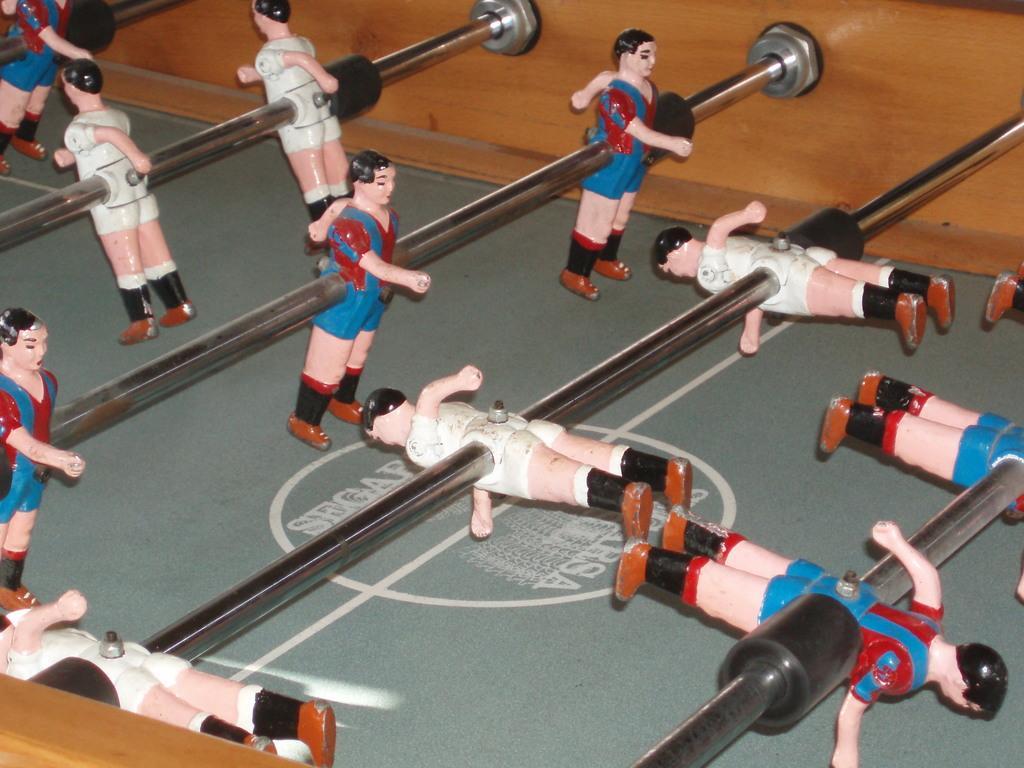Can you describe this image briefly? This is a table football game. In this there are bars with figures on that. This bars are attached to a wooden wall. Also there is a logo on the table. 